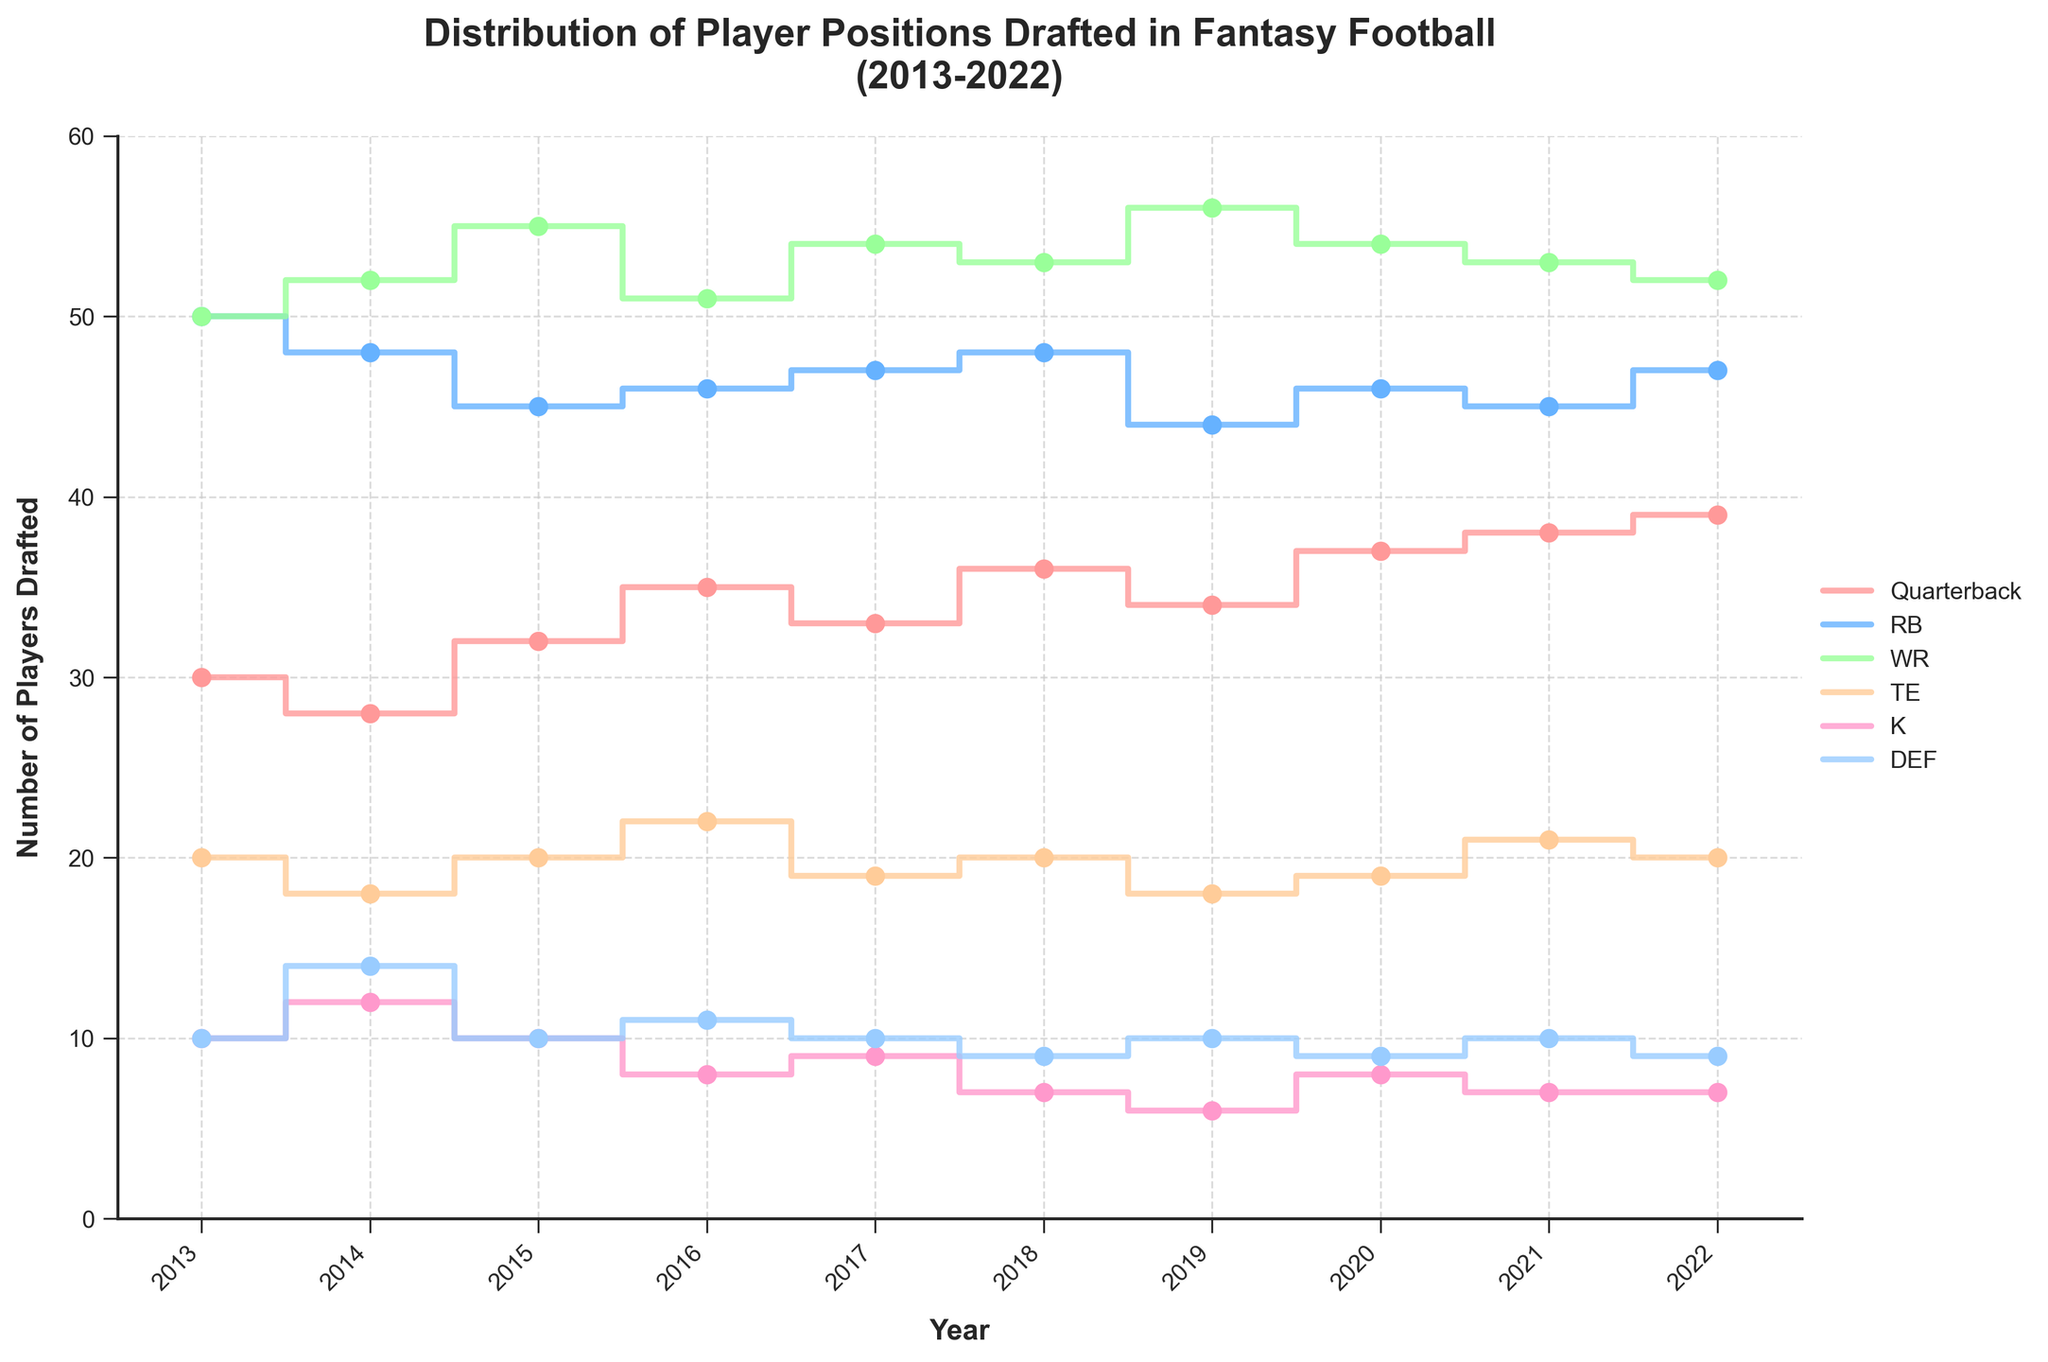What is the title of the plot? The title of the plot is usually positioned at the top of the figure and is designed to give an overview of what the plot is about. Here, the title reads, "Distribution of Player Positions Drafted in Fantasy Football (2013-2022)."
Answer: Distribution of Player Positions Drafted in Fantasy Football (2013-2022) How many positions are shown in the plot, and can you list them? The legend helps identify the different lines in the plot, each representing a different player position. According to the legend, there are six positions: Quarterback, RB, WR, TE, K, and DEF.
Answer: Six; Quarterback, RB, WR, TE, K, DEF Which position saw the most significant increase in the number of players drafted from 2013 to 2022? To answer this, you need to compare the values at 2013 and 2022 for each position. Quarterbacks increased from 30 to 39, RBs decreased from 50 to 47, WRs increased from 50 to 52, TEs remained at 20, Ks remained at 7, and DEF remained at 9. The largest increase was in Quarterbacks, from 30 to 39, which is an increase of 9 players.
Answer: Quarterbacks In which year was the number of Wide Receivers (WR) drafted the highest? By observing the plot for WR (usually one line with a specific color), you can see that the highest value for WRs appears in 2019, where 56 WRs were drafted.
Answer: 2019 What is the average number of Tight Ends (TE) drafted over the decade? Sum the values for TE from each year (20, 18, 20, 22, 19, 20, 18, 19, 21, 20) and divide by the number of years, which is 10. The sum is 197, so the average is 197/10 = 19.7.
Answer: 19.7 Which position saw a steady decrease in the number of players drafted over the years? By visually tracking the trend lines, you can see that the K (Kicker) line has a steady downward trend from 10 in 2013 to 7 in 2022.
Answer: Kicker (K) What was the number of Running Backs (RB) drafted in 2016, and how did it compare to 2015? Look at the values for RB in 2016 (46) and in 2015 (45). The number of RBs drafted in 2016 was 46, which is 1 more than in 2015 where 45 RBs were drafted.
Answer: 46 in 2016; 1 more than in 2015 How many more Wide Receivers (WR) than Quarterbacks (QB) were drafted in 2022? In 2022, the number of WRs drafted was 52, and the number of QBs was 39. Subtract the number of QBs from WRs to get the difference: 52 - 39 = 13.
Answer: 13 more What is the general trend for Defenses (DEF) drafted over the decade? By observing the plot for DEF, you can see that the line remains relatively flat, starting at 10 in 2013 and ending at 9 in 2022, indicating a general stable trend with no significant increases or decreases.
Answer: Relatively stable 